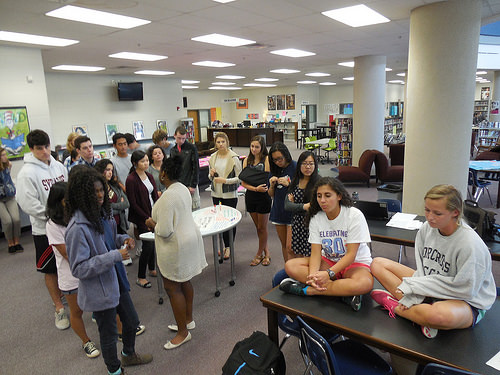<image>
Can you confirm if the girl is behind the table? No. The girl is not behind the table. From this viewpoint, the girl appears to be positioned elsewhere in the scene. Is the woman behind the table? No. The woman is not behind the table. From this viewpoint, the woman appears to be positioned elsewhere in the scene. 